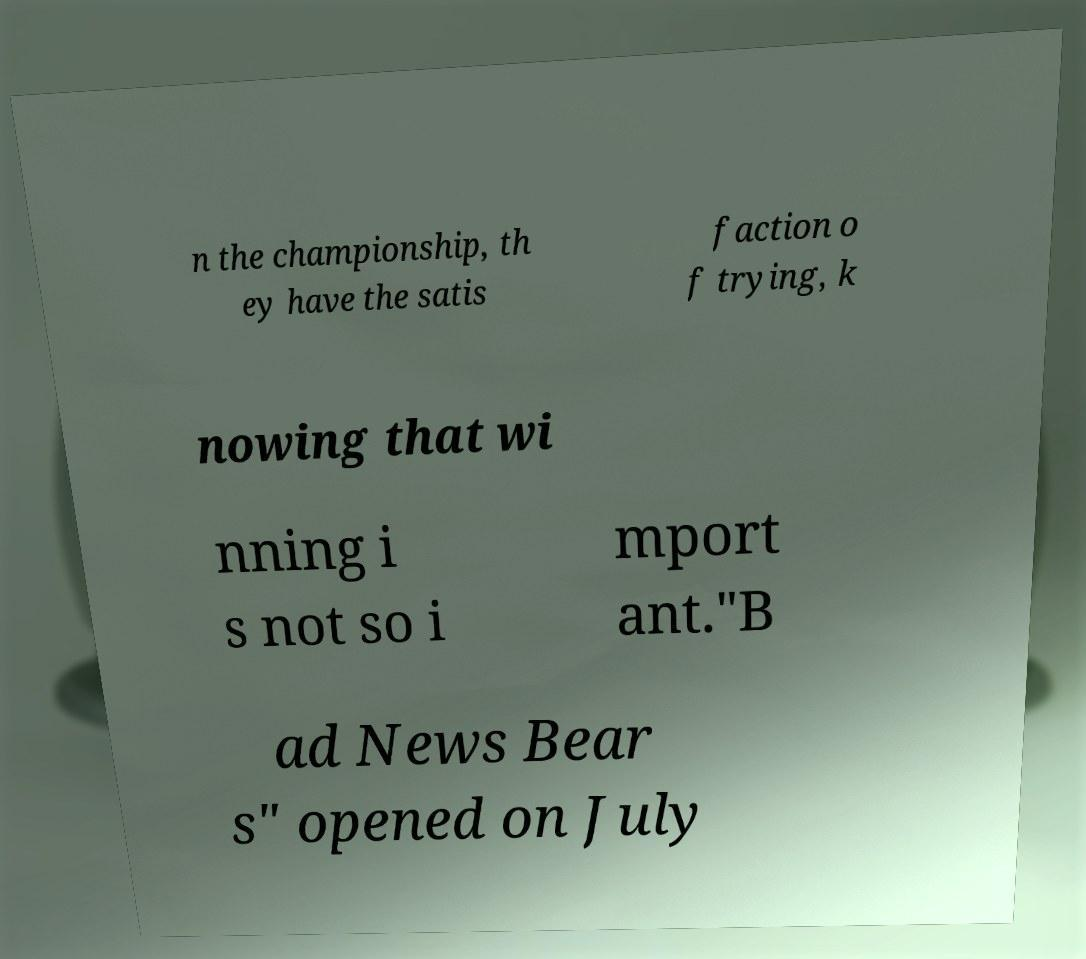What messages or text are displayed in this image? I need them in a readable, typed format. n the championship, th ey have the satis faction o f trying, k nowing that wi nning i s not so i mport ant."B ad News Bear s" opened on July 